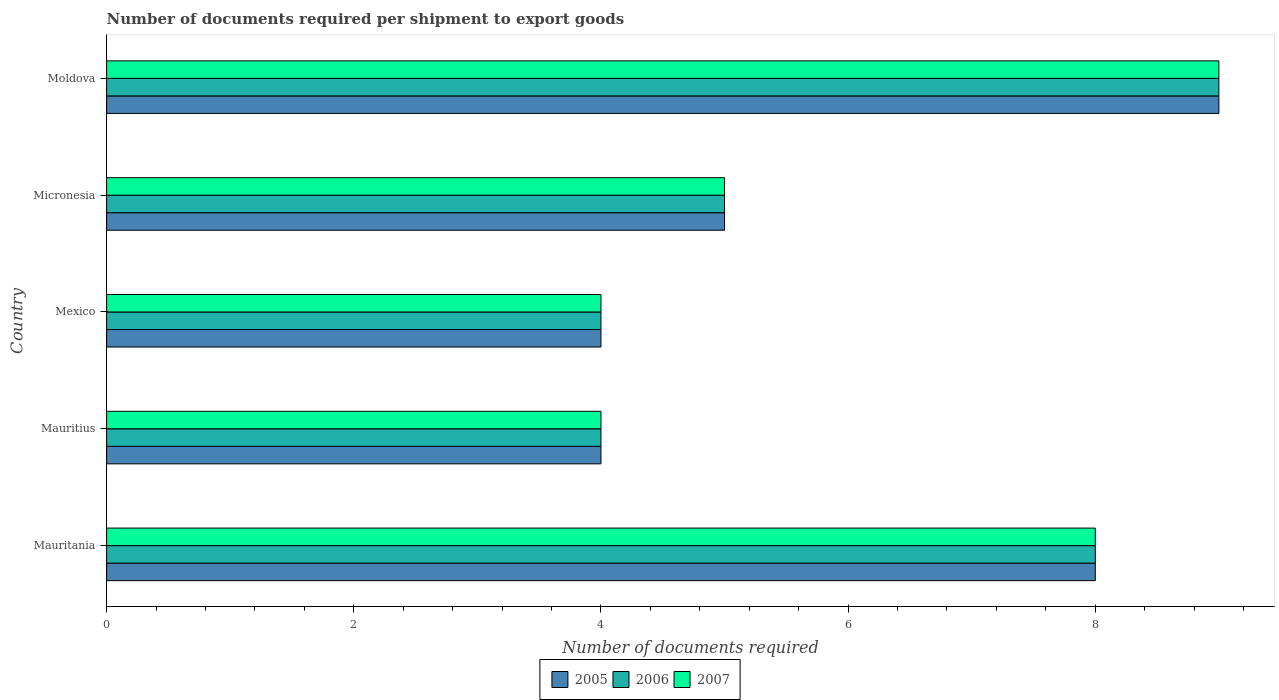How many groups of bars are there?
Provide a succinct answer. 5. How many bars are there on the 3rd tick from the top?
Provide a short and direct response. 3. What is the label of the 4th group of bars from the top?
Give a very brief answer. Mauritius. Across all countries, what is the maximum number of documents required per shipment to export goods in 2005?
Provide a short and direct response. 9. Across all countries, what is the minimum number of documents required per shipment to export goods in 2007?
Provide a short and direct response. 4. In which country was the number of documents required per shipment to export goods in 2006 maximum?
Your answer should be compact. Moldova. In which country was the number of documents required per shipment to export goods in 2006 minimum?
Ensure brevity in your answer.  Mauritius. What is the total number of documents required per shipment to export goods in 2005 in the graph?
Keep it short and to the point. 30. What is the average number of documents required per shipment to export goods in 2007 per country?
Make the answer very short. 6. What is the ratio of the number of documents required per shipment to export goods in 2007 in Mauritius to that in Moldova?
Offer a very short reply. 0.44. Is the difference between the number of documents required per shipment to export goods in 2006 in Mauritania and Mexico greater than the difference between the number of documents required per shipment to export goods in 2005 in Mauritania and Mexico?
Your response must be concise. No. What is the difference between the highest and the lowest number of documents required per shipment to export goods in 2005?
Provide a succinct answer. 5. In how many countries, is the number of documents required per shipment to export goods in 2007 greater than the average number of documents required per shipment to export goods in 2007 taken over all countries?
Give a very brief answer. 2. What does the 3rd bar from the top in Mauritania represents?
Provide a succinct answer. 2005. Is it the case that in every country, the sum of the number of documents required per shipment to export goods in 2007 and number of documents required per shipment to export goods in 2006 is greater than the number of documents required per shipment to export goods in 2005?
Your answer should be compact. Yes. Are all the bars in the graph horizontal?
Your answer should be compact. Yes. Are the values on the major ticks of X-axis written in scientific E-notation?
Keep it short and to the point. No. How are the legend labels stacked?
Provide a short and direct response. Horizontal. What is the title of the graph?
Offer a terse response. Number of documents required per shipment to export goods. Does "2013" appear as one of the legend labels in the graph?
Make the answer very short. No. What is the label or title of the X-axis?
Your answer should be compact. Number of documents required. What is the label or title of the Y-axis?
Offer a very short reply. Country. What is the Number of documents required in 2006 in Mauritania?
Ensure brevity in your answer.  8. What is the Number of documents required of 2005 in Mauritius?
Your answer should be compact. 4. What is the Number of documents required in 2006 in Mauritius?
Give a very brief answer. 4. What is the Number of documents required in 2007 in Mauritius?
Give a very brief answer. 4. What is the Number of documents required of 2006 in Mexico?
Offer a terse response. 4. What is the Number of documents required of 2007 in Mexico?
Provide a succinct answer. 4. What is the Number of documents required in 2005 in Micronesia?
Offer a terse response. 5. What is the Number of documents required of 2007 in Micronesia?
Provide a short and direct response. 5. What is the Number of documents required of 2006 in Moldova?
Make the answer very short. 9. What is the Number of documents required in 2007 in Moldova?
Provide a succinct answer. 9. Across all countries, what is the maximum Number of documents required in 2006?
Ensure brevity in your answer.  9. Across all countries, what is the maximum Number of documents required in 2007?
Make the answer very short. 9. Across all countries, what is the minimum Number of documents required in 2007?
Provide a succinct answer. 4. What is the total Number of documents required of 2005 in the graph?
Offer a very short reply. 30. What is the difference between the Number of documents required of 2005 in Mauritania and that in Mauritius?
Your response must be concise. 4. What is the difference between the Number of documents required in 2006 in Mauritania and that in Mauritius?
Keep it short and to the point. 4. What is the difference between the Number of documents required of 2005 in Mauritania and that in Mexico?
Offer a very short reply. 4. What is the difference between the Number of documents required in 2006 in Mauritania and that in Mexico?
Ensure brevity in your answer.  4. What is the difference between the Number of documents required of 2007 in Mauritania and that in Mexico?
Provide a short and direct response. 4. What is the difference between the Number of documents required of 2005 in Mauritania and that in Micronesia?
Your response must be concise. 3. What is the difference between the Number of documents required of 2006 in Mauritania and that in Micronesia?
Make the answer very short. 3. What is the difference between the Number of documents required of 2005 in Mauritania and that in Moldova?
Make the answer very short. -1. What is the difference between the Number of documents required of 2006 in Mauritania and that in Moldova?
Provide a succinct answer. -1. What is the difference between the Number of documents required of 2007 in Mauritania and that in Moldova?
Give a very brief answer. -1. What is the difference between the Number of documents required of 2006 in Mauritius and that in Mexico?
Give a very brief answer. 0. What is the difference between the Number of documents required of 2007 in Mauritius and that in Mexico?
Offer a terse response. 0. What is the difference between the Number of documents required in 2005 in Mauritius and that in Micronesia?
Make the answer very short. -1. What is the difference between the Number of documents required of 2006 in Mauritius and that in Micronesia?
Offer a terse response. -1. What is the difference between the Number of documents required of 2007 in Mauritius and that in Micronesia?
Ensure brevity in your answer.  -1. What is the difference between the Number of documents required of 2005 in Mauritius and that in Moldova?
Keep it short and to the point. -5. What is the difference between the Number of documents required in 2007 in Mexico and that in Micronesia?
Provide a short and direct response. -1. What is the difference between the Number of documents required in 2005 in Mexico and that in Moldova?
Offer a terse response. -5. What is the difference between the Number of documents required in 2007 in Mexico and that in Moldova?
Make the answer very short. -5. What is the difference between the Number of documents required in 2006 in Micronesia and that in Moldova?
Keep it short and to the point. -4. What is the difference between the Number of documents required in 2007 in Micronesia and that in Moldova?
Give a very brief answer. -4. What is the difference between the Number of documents required in 2005 in Mauritania and the Number of documents required in 2006 in Moldova?
Provide a succinct answer. -1. What is the difference between the Number of documents required of 2005 in Mauritania and the Number of documents required of 2007 in Moldova?
Offer a terse response. -1. What is the difference between the Number of documents required of 2005 in Mauritius and the Number of documents required of 2007 in Mexico?
Your answer should be compact. 0. What is the difference between the Number of documents required of 2006 in Mauritius and the Number of documents required of 2007 in Micronesia?
Ensure brevity in your answer.  -1. What is the difference between the Number of documents required of 2005 in Mauritius and the Number of documents required of 2007 in Moldova?
Your answer should be very brief. -5. What is the difference between the Number of documents required of 2006 in Mauritius and the Number of documents required of 2007 in Moldova?
Offer a very short reply. -5. What is the difference between the Number of documents required in 2005 in Mexico and the Number of documents required in 2006 in Micronesia?
Your answer should be compact. -1. What is the difference between the Number of documents required of 2005 in Mexico and the Number of documents required of 2007 in Micronesia?
Offer a terse response. -1. What is the difference between the Number of documents required in 2006 in Mexico and the Number of documents required in 2007 in Micronesia?
Ensure brevity in your answer.  -1. What is the difference between the Number of documents required of 2005 in Mexico and the Number of documents required of 2007 in Moldova?
Make the answer very short. -5. What is the difference between the Number of documents required of 2006 in Mexico and the Number of documents required of 2007 in Moldova?
Offer a terse response. -5. What is the difference between the Number of documents required of 2005 in Micronesia and the Number of documents required of 2006 in Moldova?
Provide a short and direct response. -4. What is the difference between the Number of documents required of 2005 in Micronesia and the Number of documents required of 2007 in Moldova?
Your answer should be very brief. -4. What is the difference between the Number of documents required in 2006 in Micronesia and the Number of documents required in 2007 in Moldova?
Keep it short and to the point. -4. What is the average Number of documents required in 2006 per country?
Offer a terse response. 6. What is the average Number of documents required in 2007 per country?
Offer a terse response. 6. What is the difference between the Number of documents required of 2005 and Number of documents required of 2006 in Mauritius?
Ensure brevity in your answer.  0. What is the difference between the Number of documents required of 2005 and Number of documents required of 2006 in Mexico?
Provide a short and direct response. 0. What is the difference between the Number of documents required of 2005 and Number of documents required of 2007 in Mexico?
Offer a terse response. 0. What is the difference between the Number of documents required of 2005 and Number of documents required of 2006 in Micronesia?
Your response must be concise. 0. What is the difference between the Number of documents required of 2005 and Number of documents required of 2007 in Micronesia?
Your answer should be compact. 0. What is the difference between the Number of documents required of 2005 and Number of documents required of 2006 in Moldova?
Give a very brief answer. 0. What is the ratio of the Number of documents required in 2005 in Mauritania to that in Mauritius?
Your answer should be very brief. 2. What is the ratio of the Number of documents required of 2006 in Mauritania to that in Mauritius?
Ensure brevity in your answer.  2. What is the ratio of the Number of documents required in 2007 in Mauritania to that in Mauritius?
Provide a succinct answer. 2. What is the ratio of the Number of documents required in 2007 in Mauritania to that in Mexico?
Offer a very short reply. 2. What is the ratio of the Number of documents required of 2007 in Mauritania to that in Micronesia?
Your answer should be compact. 1.6. What is the ratio of the Number of documents required in 2005 in Mauritania to that in Moldova?
Make the answer very short. 0.89. What is the ratio of the Number of documents required in 2005 in Mauritius to that in Micronesia?
Offer a very short reply. 0.8. What is the ratio of the Number of documents required in 2005 in Mauritius to that in Moldova?
Give a very brief answer. 0.44. What is the ratio of the Number of documents required in 2006 in Mauritius to that in Moldova?
Your answer should be compact. 0.44. What is the ratio of the Number of documents required in 2007 in Mauritius to that in Moldova?
Provide a succinct answer. 0.44. What is the ratio of the Number of documents required in 2006 in Mexico to that in Micronesia?
Your response must be concise. 0.8. What is the ratio of the Number of documents required of 2007 in Mexico to that in Micronesia?
Your answer should be very brief. 0.8. What is the ratio of the Number of documents required in 2005 in Mexico to that in Moldova?
Your answer should be very brief. 0.44. What is the ratio of the Number of documents required in 2006 in Mexico to that in Moldova?
Keep it short and to the point. 0.44. What is the ratio of the Number of documents required in 2007 in Mexico to that in Moldova?
Make the answer very short. 0.44. What is the ratio of the Number of documents required in 2005 in Micronesia to that in Moldova?
Your answer should be very brief. 0.56. What is the ratio of the Number of documents required in 2006 in Micronesia to that in Moldova?
Your answer should be compact. 0.56. What is the ratio of the Number of documents required of 2007 in Micronesia to that in Moldova?
Provide a succinct answer. 0.56. What is the difference between the highest and the second highest Number of documents required in 2005?
Your answer should be compact. 1. What is the difference between the highest and the second highest Number of documents required of 2006?
Offer a terse response. 1. What is the difference between the highest and the lowest Number of documents required in 2007?
Provide a succinct answer. 5. 